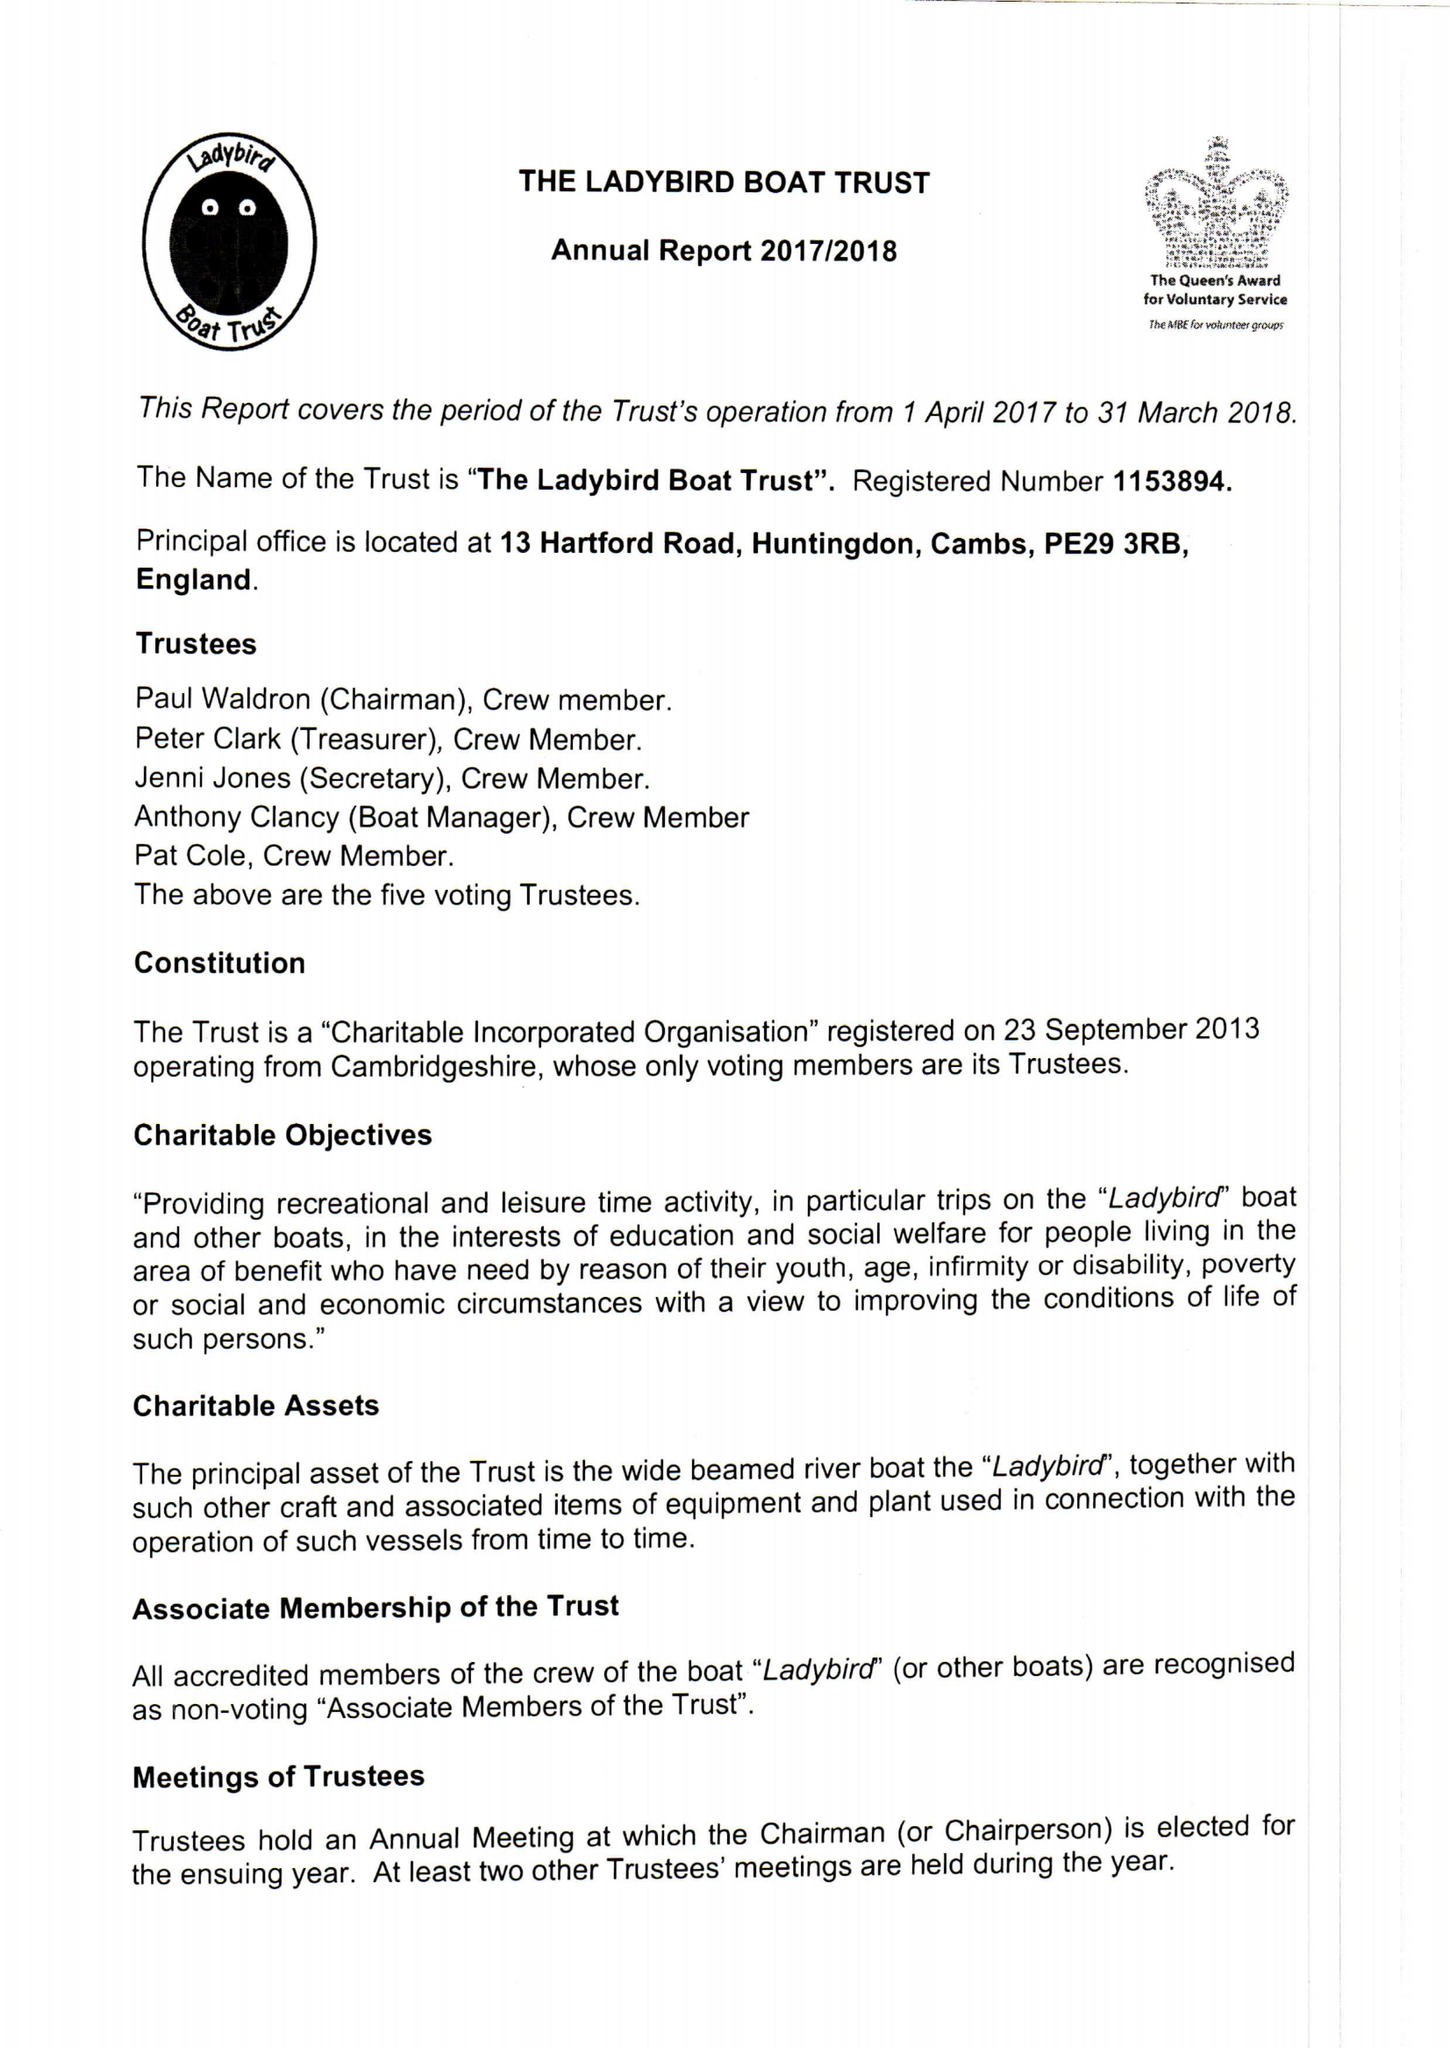What is the value for the charity_number?
Answer the question using a single word or phrase. 1153894 